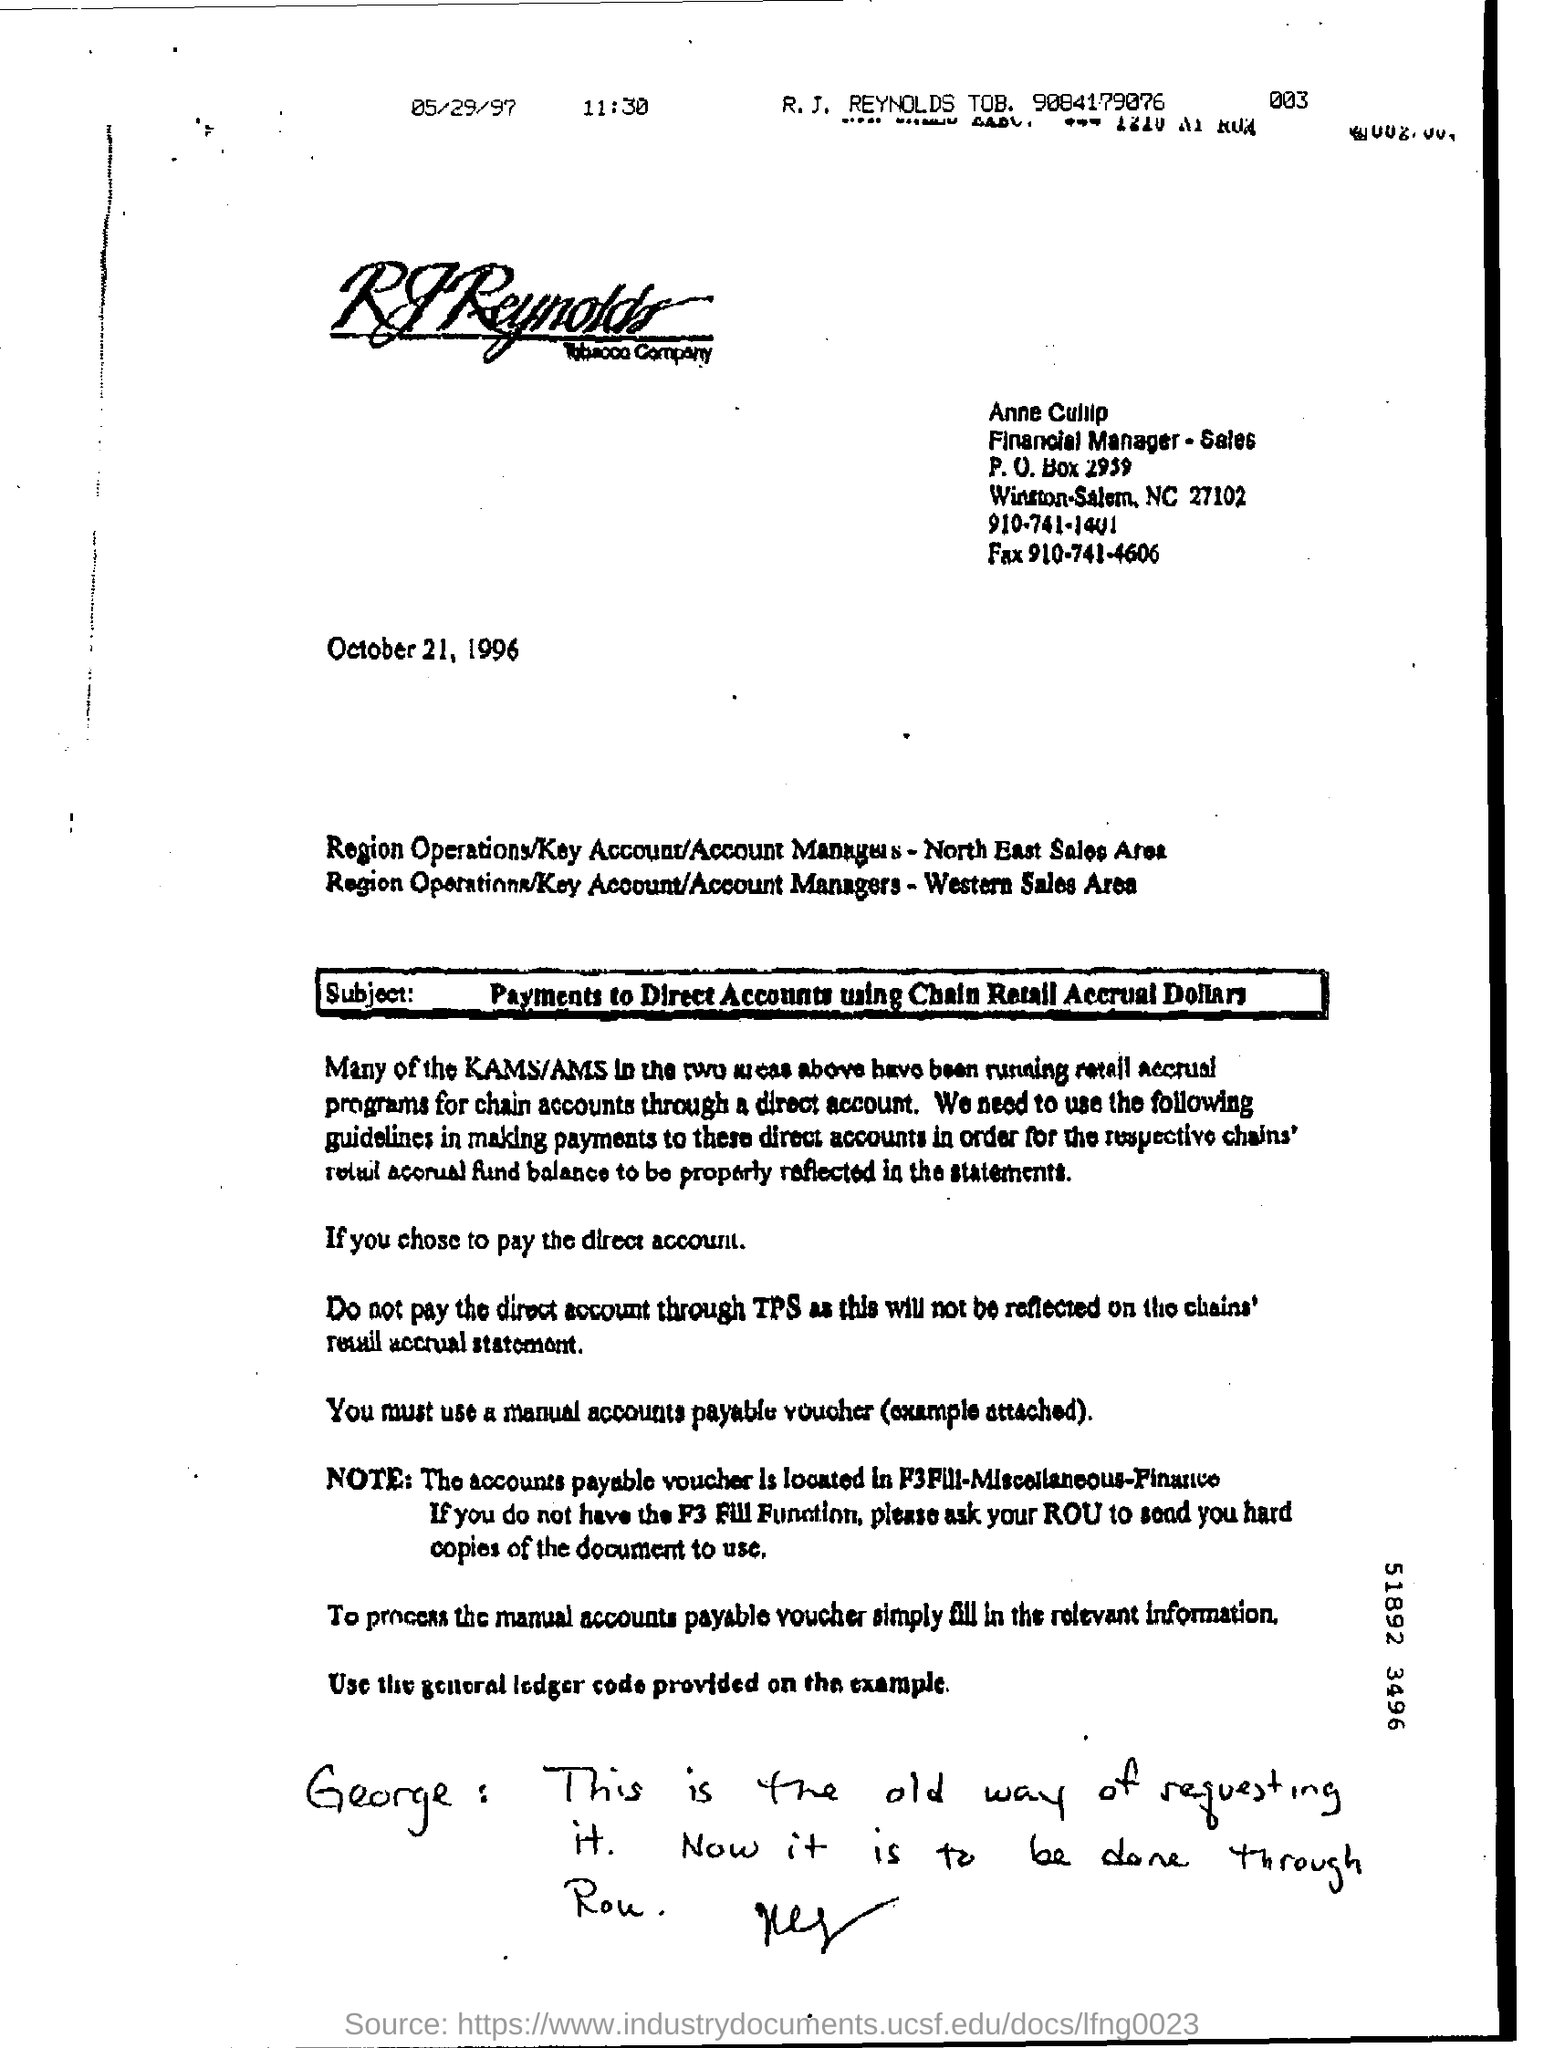Indicate a few pertinent items in this graphic. The letter head mentions a company that is associated with tobacco. This letter is dated October 21, 1996. The subject mentioned in the letter is the use of Chain Retail Accrual Dollars for making payments to Direct Accounts. 